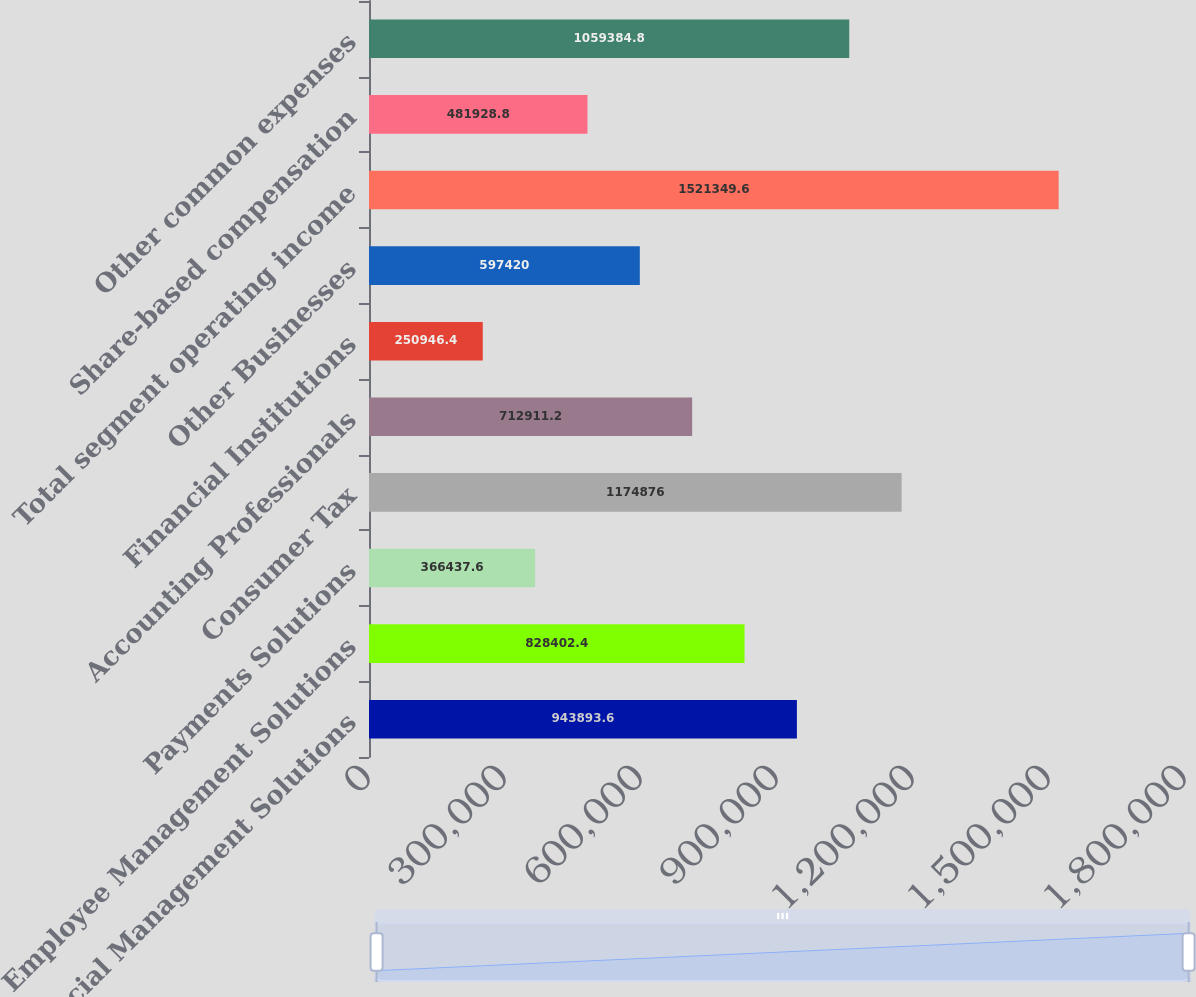<chart> <loc_0><loc_0><loc_500><loc_500><bar_chart><fcel>Financial Management Solutions<fcel>Employee Management Solutions<fcel>Payments Solutions<fcel>Consumer Tax<fcel>Accounting Professionals<fcel>Financial Institutions<fcel>Other Businesses<fcel>Total segment operating income<fcel>Share-based compensation<fcel>Other common expenses<nl><fcel>943894<fcel>828402<fcel>366438<fcel>1.17488e+06<fcel>712911<fcel>250946<fcel>597420<fcel>1.52135e+06<fcel>481929<fcel>1.05938e+06<nl></chart> 